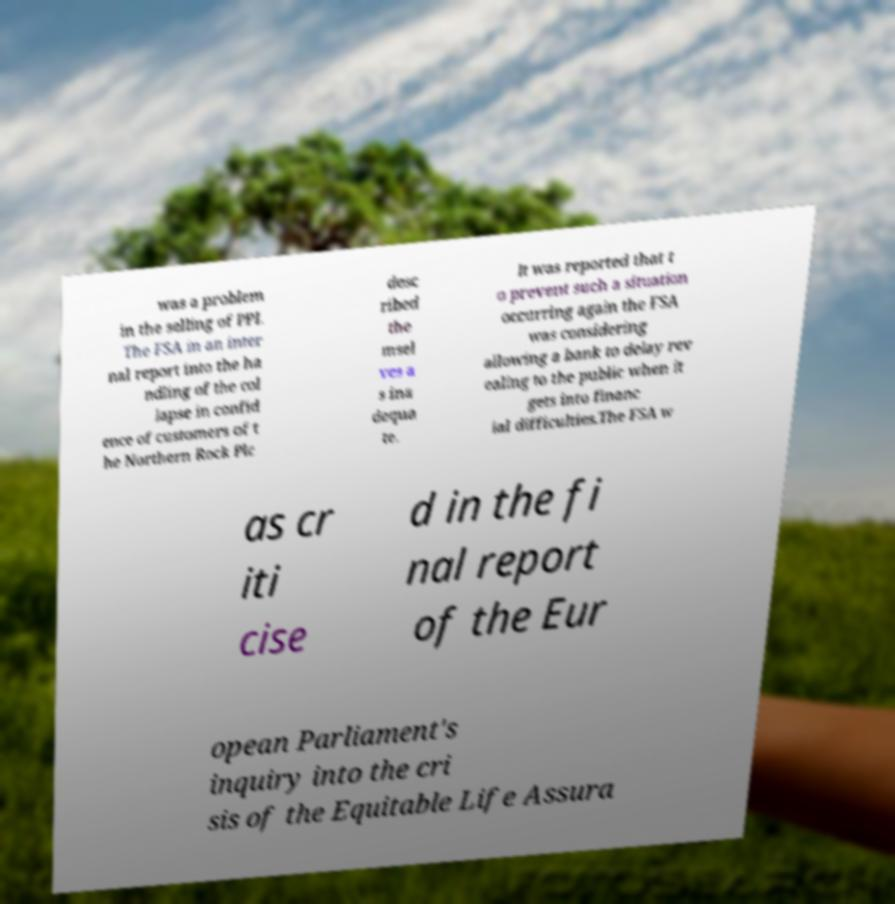For documentation purposes, I need the text within this image transcribed. Could you provide that? was a problem in the selling of PPI. The FSA in an inter nal report into the ha ndling of the col lapse in confid ence of customers of t he Northern Rock Plc desc ribed the msel ves a s ina dequa te. It was reported that t o prevent such a situation occurring again the FSA was considering allowing a bank to delay rev ealing to the public when it gets into financ ial difficulties.The FSA w as cr iti cise d in the fi nal report of the Eur opean Parliament's inquiry into the cri sis of the Equitable Life Assura 